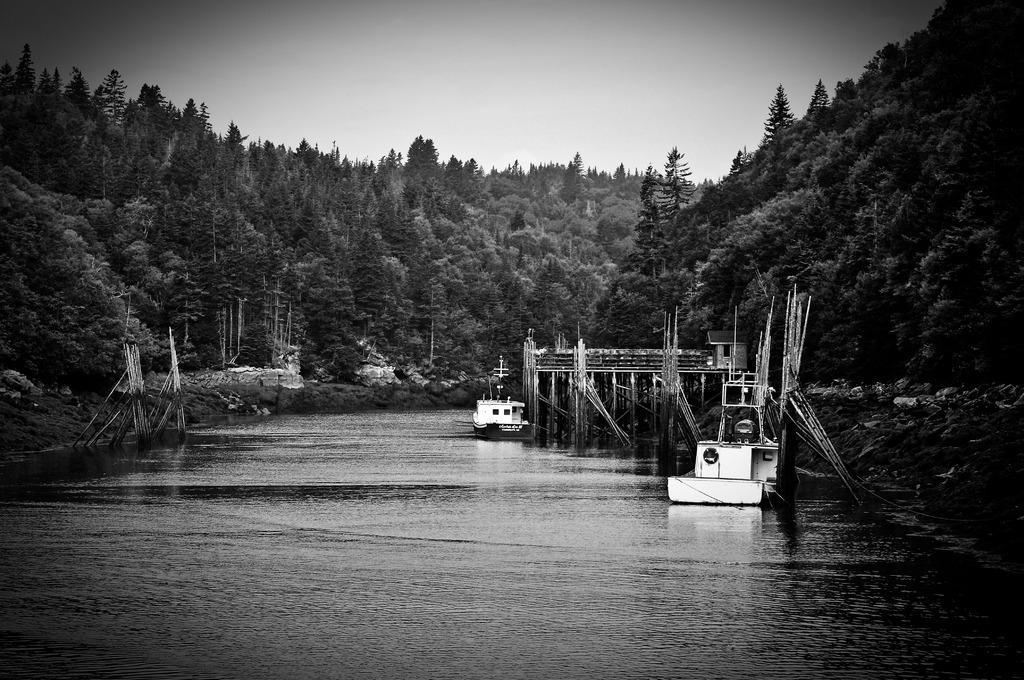Describe this image in one or two sentences. This is a black and white image where we can see a surface of water at the bottom of this image and trees in the background. The sky is at the top of this image. 